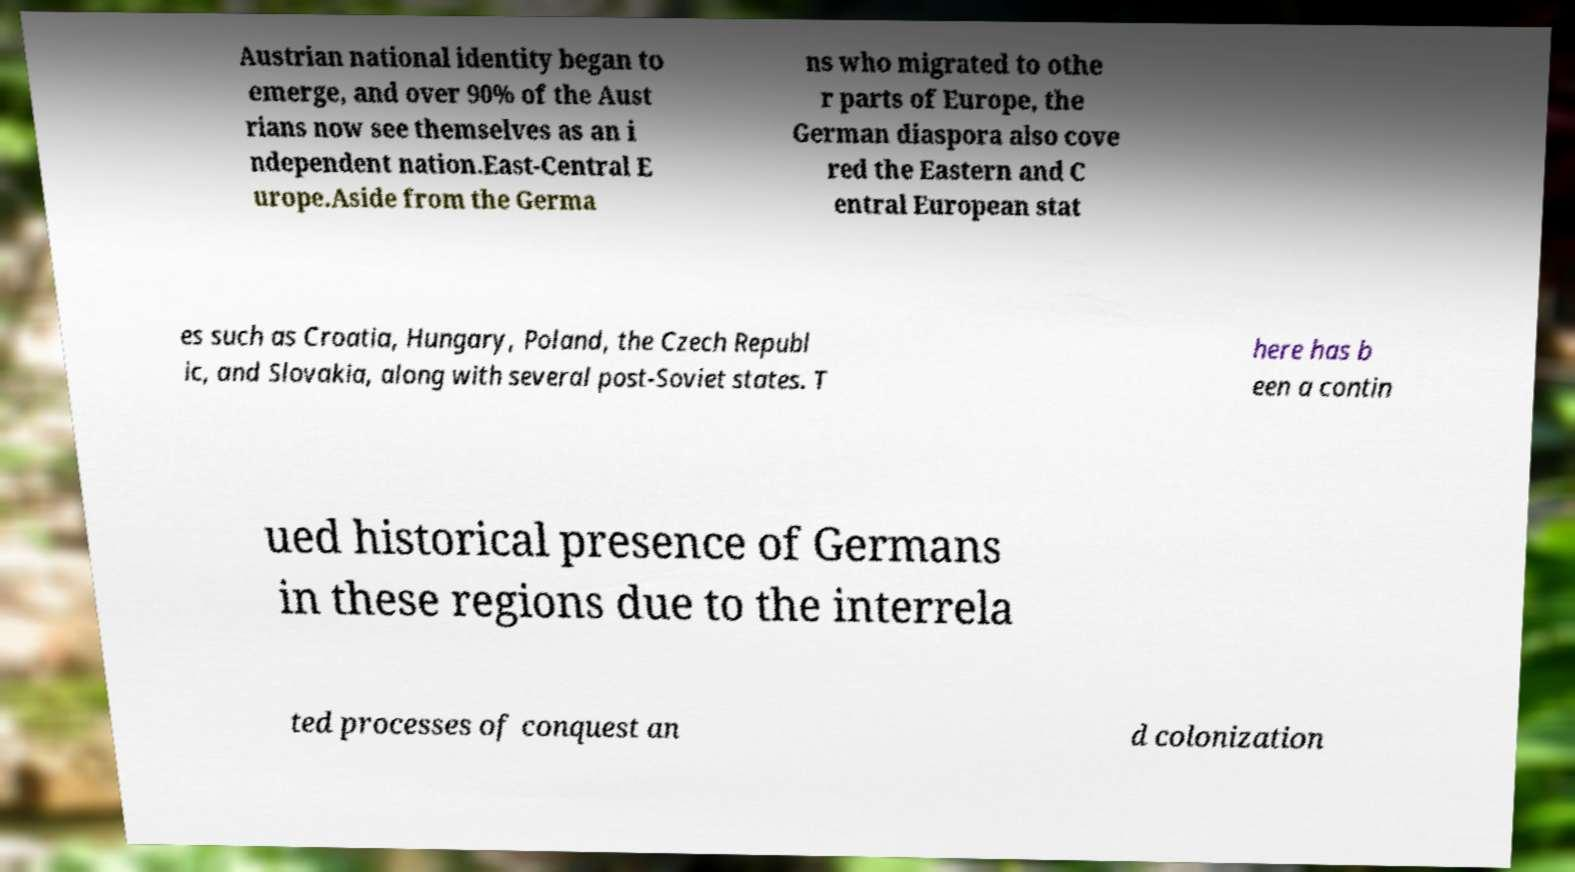Can you read and provide the text displayed in the image?This photo seems to have some interesting text. Can you extract and type it out for me? Austrian national identity began to emerge, and over 90% of the Aust rians now see themselves as an i ndependent nation.East-Central E urope.Aside from the Germa ns who migrated to othe r parts of Europe, the German diaspora also cove red the Eastern and C entral European stat es such as Croatia, Hungary, Poland, the Czech Republ ic, and Slovakia, along with several post-Soviet states. T here has b een a contin ued historical presence of Germans in these regions due to the interrela ted processes of conquest an d colonization 